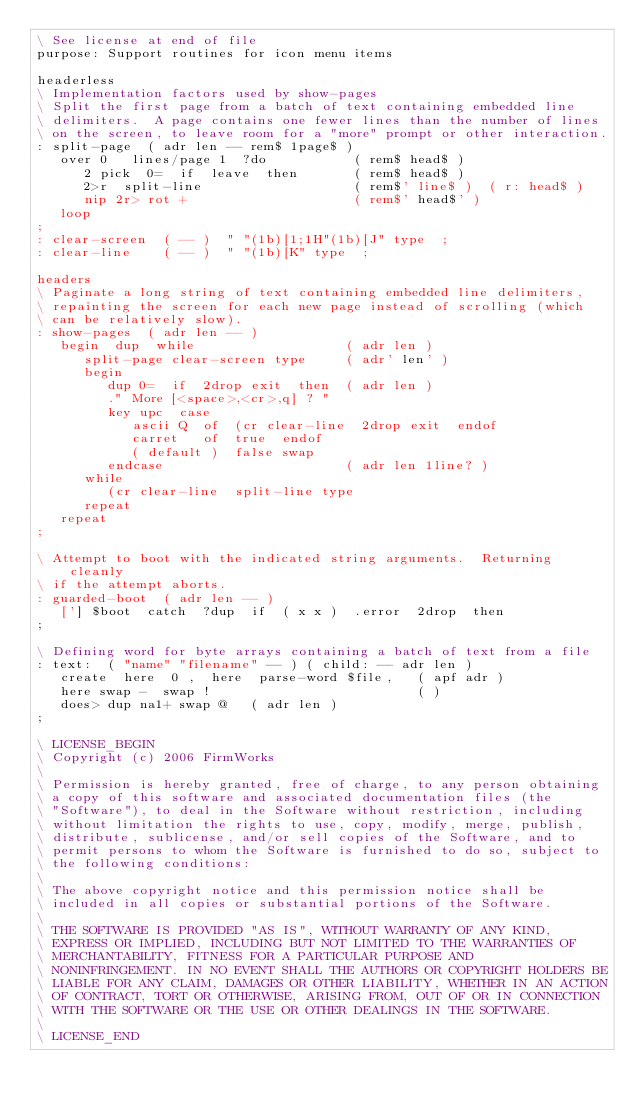Convert code to text. <code><loc_0><loc_0><loc_500><loc_500><_Forth_>\ See license at end of file
purpose: Support routines for icon menu items

headerless
\ Implementation factors used by show-pages
\ Split the first page from a batch of text containing embedded line
\ delimiters.  A page contains one fewer lines than the number of lines
\ on the screen, to leave room for a "more" prompt or other interaction.
: split-page  ( adr len -- rem$ 1page$ )
   over 0   lines/page 1  ?do           ( rem$ head$ )
      2 pick  0=  if  leave  then       ( rem$ head$ )
      2>r  split-line                   ( rem$' line$ )  ( r: head$ )
      nip 2r> rot +                     ( rem$' head$' )
   loop
;
: clear-screen  ( -- )  " "(1b)[1;1H"(1b)[J" type  ;
: clear-line    ( -- )  " "(1b)[K" type  ;

headers
\ Paginate a long string of text containing embedded line delimiters,
\ repainting the screen for each new page instead of scrolling (which
\ can be relatively slow).
: show-pages  ( adr len -- )
   begin  dup  while                   ( adr len )
      split-page clear-screen type     ( adr' len' )
      begin
         dup 0=  if  2drop exit  then  ( adr len )
         ." More [<space>,<cr>,q] ? "
         key upc  case
            ascii Q  of  (cr clear-line  2drop exit  endof
            carret   of  true  endof
            ( default )  false swap
         endcase                       ( adr len 1line? )
      while
         (cr clear-line  split-line type
      repeat
   repeat
;

\ Attempt to boot with the indicated string arguments.  Returning cleanly
\ if the attempt aborts.
: guarded-boot  ( adr len -- )
   ['] $boot  catch  ?dup  if  ( x x )  .error  2drop  then
;

\ Defining word for byte arrays containing a batch of text from a file
: text:  ( "name" "filename" -- ) ( child: -- adr len )
   create  here  0 ,  here  parse-word $file,   ( apf adr )
   here swap -  swap !                          ( )
   does> dup na1+ swap @   ( adr len )
;

\ LICENSE_BEGIN
\ Copyright (c) 2006 FirmWorks
\ 
\ Permission is hereby granted, free of charge, to any person obtaining
\ a copy of this software and associated documentation files (the
\ "Software"), to deal in the Software without restriction, including
\ without limitation the rights to use, copy, modify, merge, publish,
\ distribute, sublicense, and/or sell copies of the Software, and to
\ permit persons to whom the Software is furnished to do so, subject to
\ the following conditions:
\ 
\ The above copyright notice and this permission notice shall be
\ included in all copies or substantial portions of the Software.
\ 
\ THE SOFTWARE IS PROVIDED "AS IS", WITHOUT WARRANTY OF ANY KIND,
\ EXPRESS OR IMPLIED, INCLUDING BUT NOT LIMITED TO THE WARRANTIES OF
\ MERCHANTABILITY, FITNESS FOR A PARTICULAR PURPOSE AND
\ NONINFRINGEMENT. IN NO EVENT SHALL THE AUTHORS OR COPYRIGHT HOLDERS BE
\ LIABLE FOR ANY CLAIM, DAMAGES OR OTHER LIABILITY, WHETHER IN AN ACTION
\ OF CONTRACT, TORT OR OTHERWISE, ARISING FROM, OUT OF OR IN CONNECTION
\ WITH THE SOFTWARE OR THE USE OR OTHER DEALINGS IN THE SOFTWARE.
\
\ LICENSE_END
</code> 